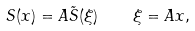<formula> <loc_0><loc_0><loc_500><loc_500>S ( x ) = A \tilde { S } ( \xi ) \quad \xi = A x ,</formula> 